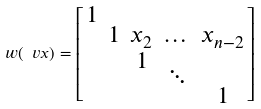<formula> <loc_0><loc_0><loc_500><loc_500>w ( \ v x ) = \left [ \begin{smallmatrix} 1 \\ & 1 & x _ { 2 } & \dots & x _ { n - 2 } \\ & & 1 \\ & & & \ddots \\ & & & & 1 \end{smallmatrix} \right ]</formula> 